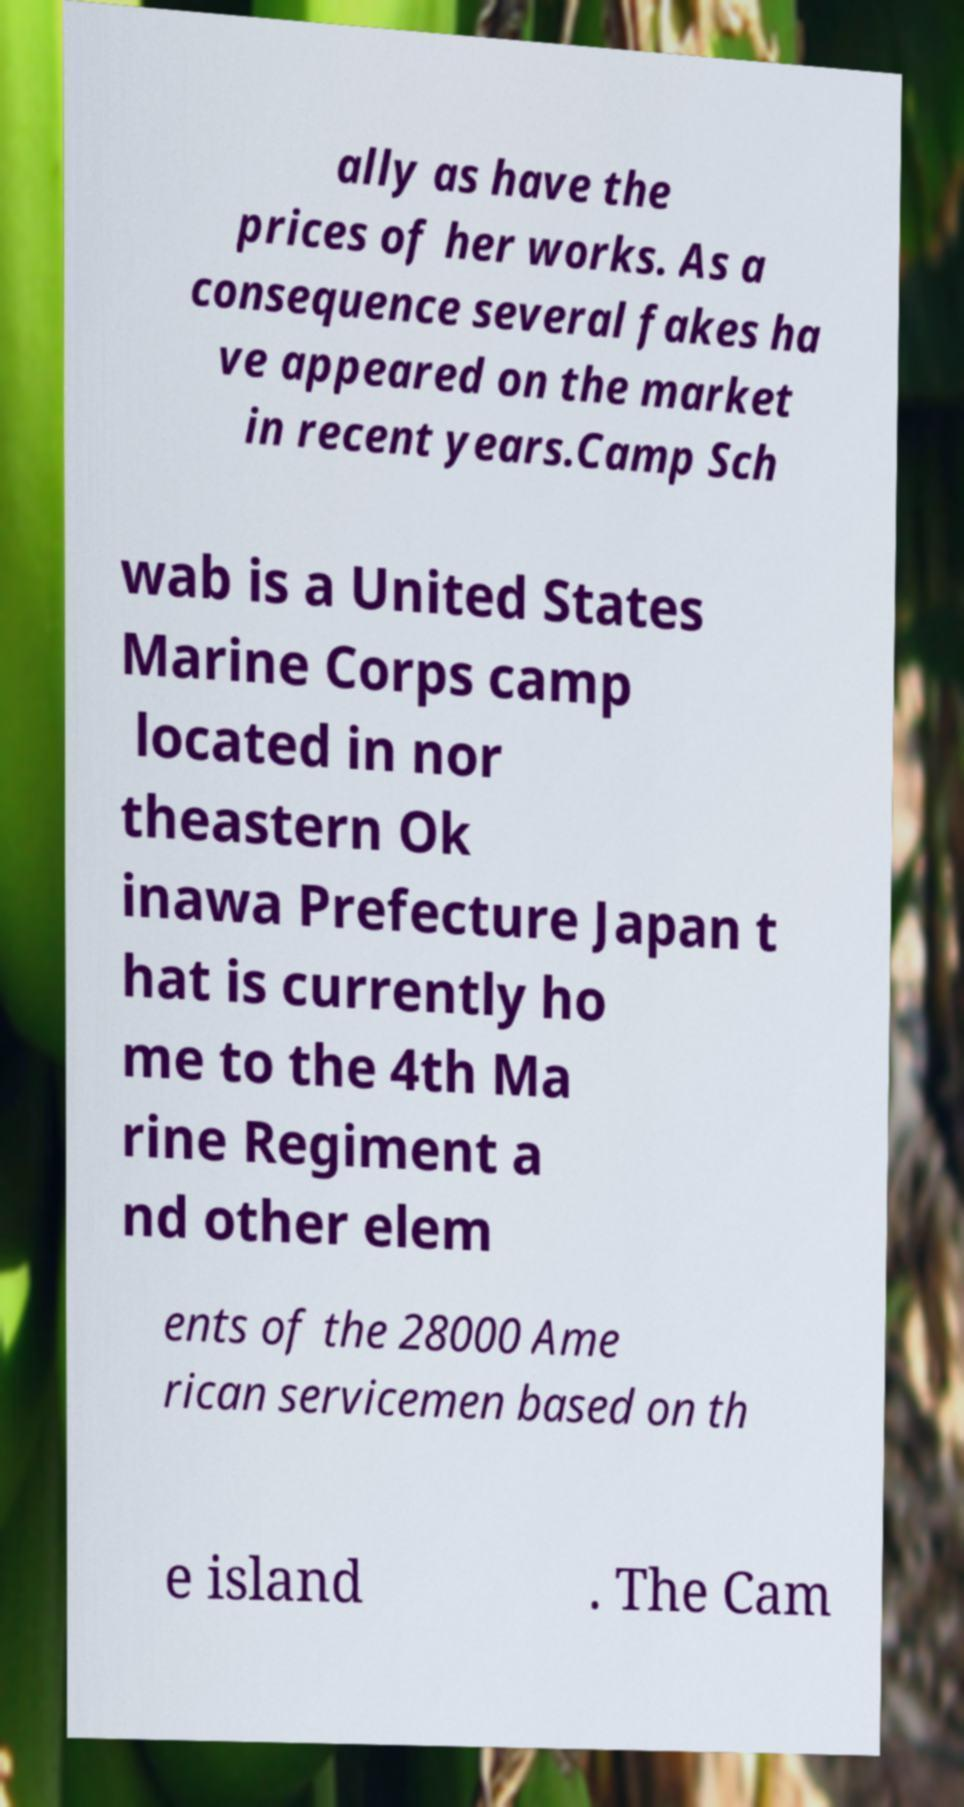For documentation purposes, I need the text within this image transcribed. Could you provide that? ally as have the prices of her works. As a consequence several fakes ha ve appeared on the market in recent years.Camp Sch wab is a United States Marine Corps camp located in nor theastern Ok inawa Prefecture Japan t hat is currently ho me to the 4th Ma rine Regiment a nd other elem ents of the 28000 Ame rican servicemen based on th e island . The Cam 